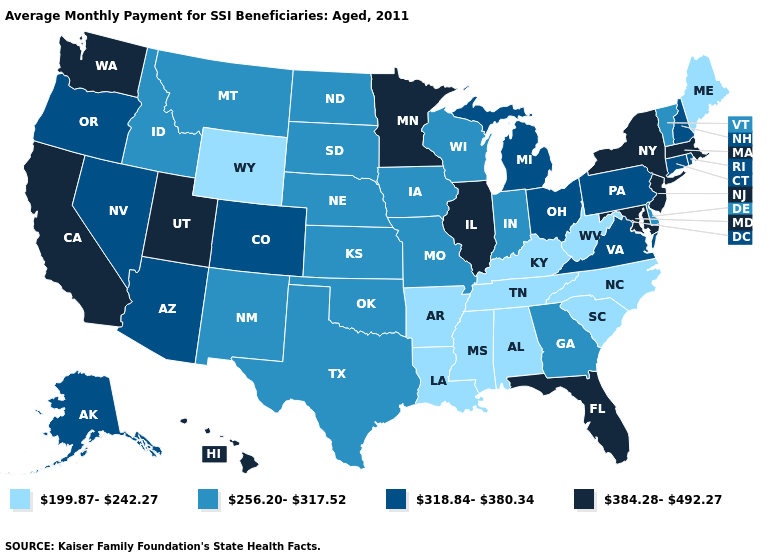Among the states that border Montana , does South Dakota have the lowest value?
Write a very short answer. No. Name the states that have a value in the range 384.28-492.27?
Give a very brief answer. California, Florida, Hawaii, Illinois, Maryland, Massachusetts, Minnesota, New Jersey, New York, Utah, Washington. What is the value of South Dakota?
Give a very brief answer. 256.20-317.52. Among the states that border Indiana , does Kentucky have the highest value?
Quick response, please. No. Name the states that have a value in the range 318.84-380.34?
Write a very short answer. Alaska, Arizona, Colorado, Connecticut, Michigan, Nevada, New Hampshire, Ohio, Oregon, Pennsylvania, Rhode Island, Virginia. Is the legend a continuous bar?
Keep it brief. No. What is the value of Arkansas?
Keep it brief. 199.87-242.27. Does the first symbol in the legend represent the smallest category?
Keep it brief. Yes. Among the states that border Texas , which have the lowest value?
Short answer required. Arkansas, Louisiana. What is the lowest value in the South?
Short answer required. 199.87-242.27. What is the value of Utah?
Answer briefly. 384.28-492.27. Among the states that border Oregon , which have the highest value?
Give a very brief answer. California, Washington. Does the map have missing data?
Short answer required. No. Name the states that have a value in the range 256.20-317.52?
Concise answer only. Delaware, Georgia, Idaho, Indiana, Iowa, Kansas, Missouri, Montana, Nebraska, New Mexico, North Dakota, Oklahoma, South Dakota, Texas, Vermont, Wisconsin. Does Indiana have the highest value in the MidWest?
Concise answer only. No. 